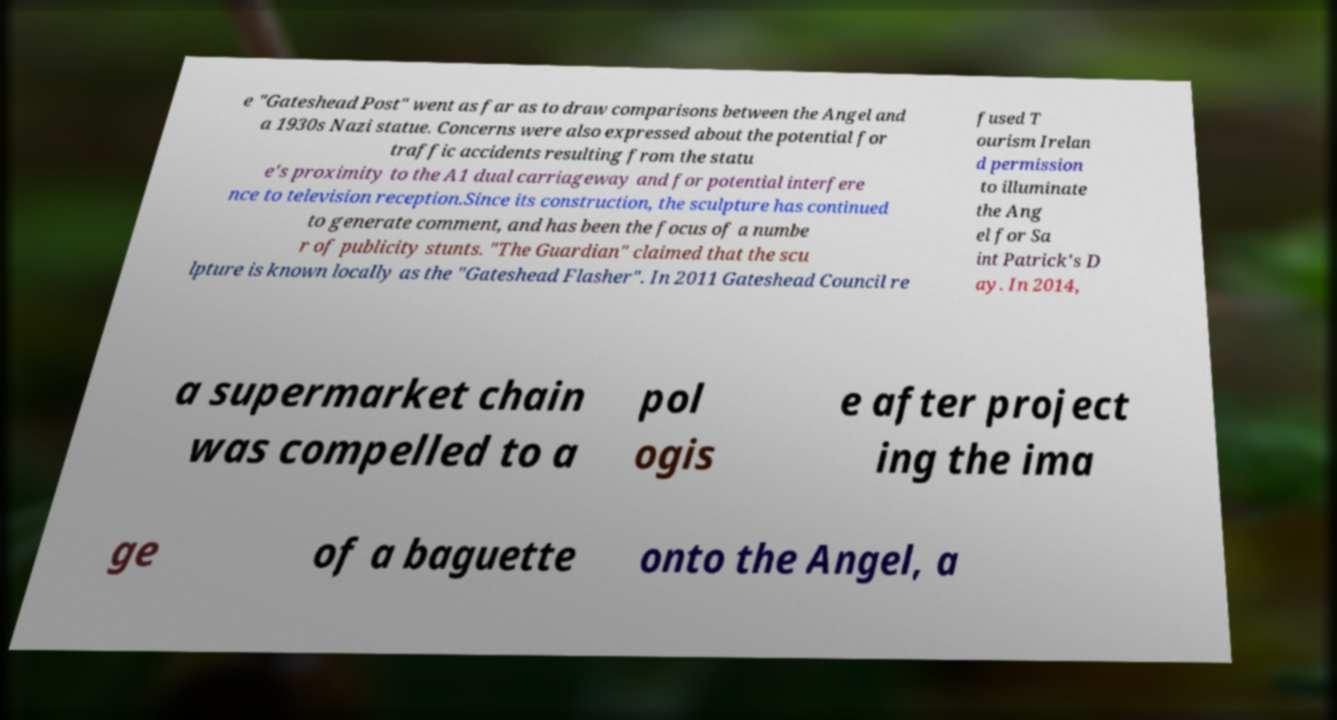I need the written content from this picture converted into text. Can you do that? e "Gateshead Post" went as far as to draw comparisons between the Angel and a 1930s Nazi statue. Concerns were also expressed about the potential for traffic accidents resulting from the statu e's proximity to the A1 dual carriageway and for potential interfere nce to television reception.Since its construction, the sculpture has continued to generate comment, and has been the focus of a numbe r of publicity stunts. "The Guardian" claimed that the scu lpture is known locally as the "Gateshead Flasher". In 2011 Gateshead Council re fused T ourism Irelan d permission to illuminate the Ang el for Sa int Patrick's D ay. In 2014, a supermarket chain was compelled to a pol ogis e after project ing the ima ge of a baguette onto the Angel, a 